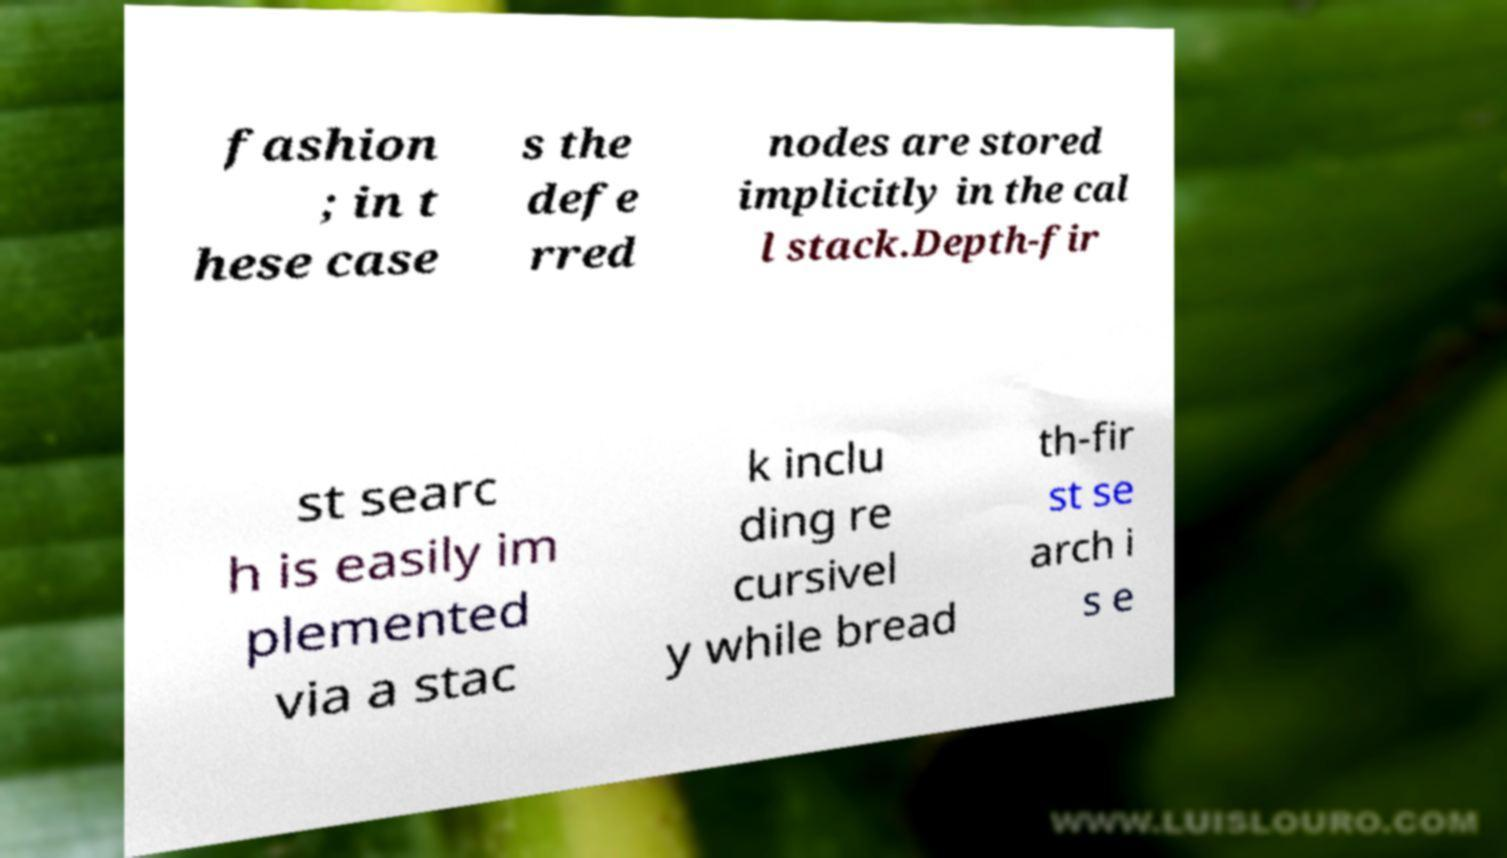I need the written content from this picture converted into text. Can you do that? fashion ; in t hese case s the defe rred nodes are stored implicitly in the cal l stack.Depth-fir st searc h is easily im plemented via a stac k inclu ding re cursivel y while bread th-fir st se arch i s e 